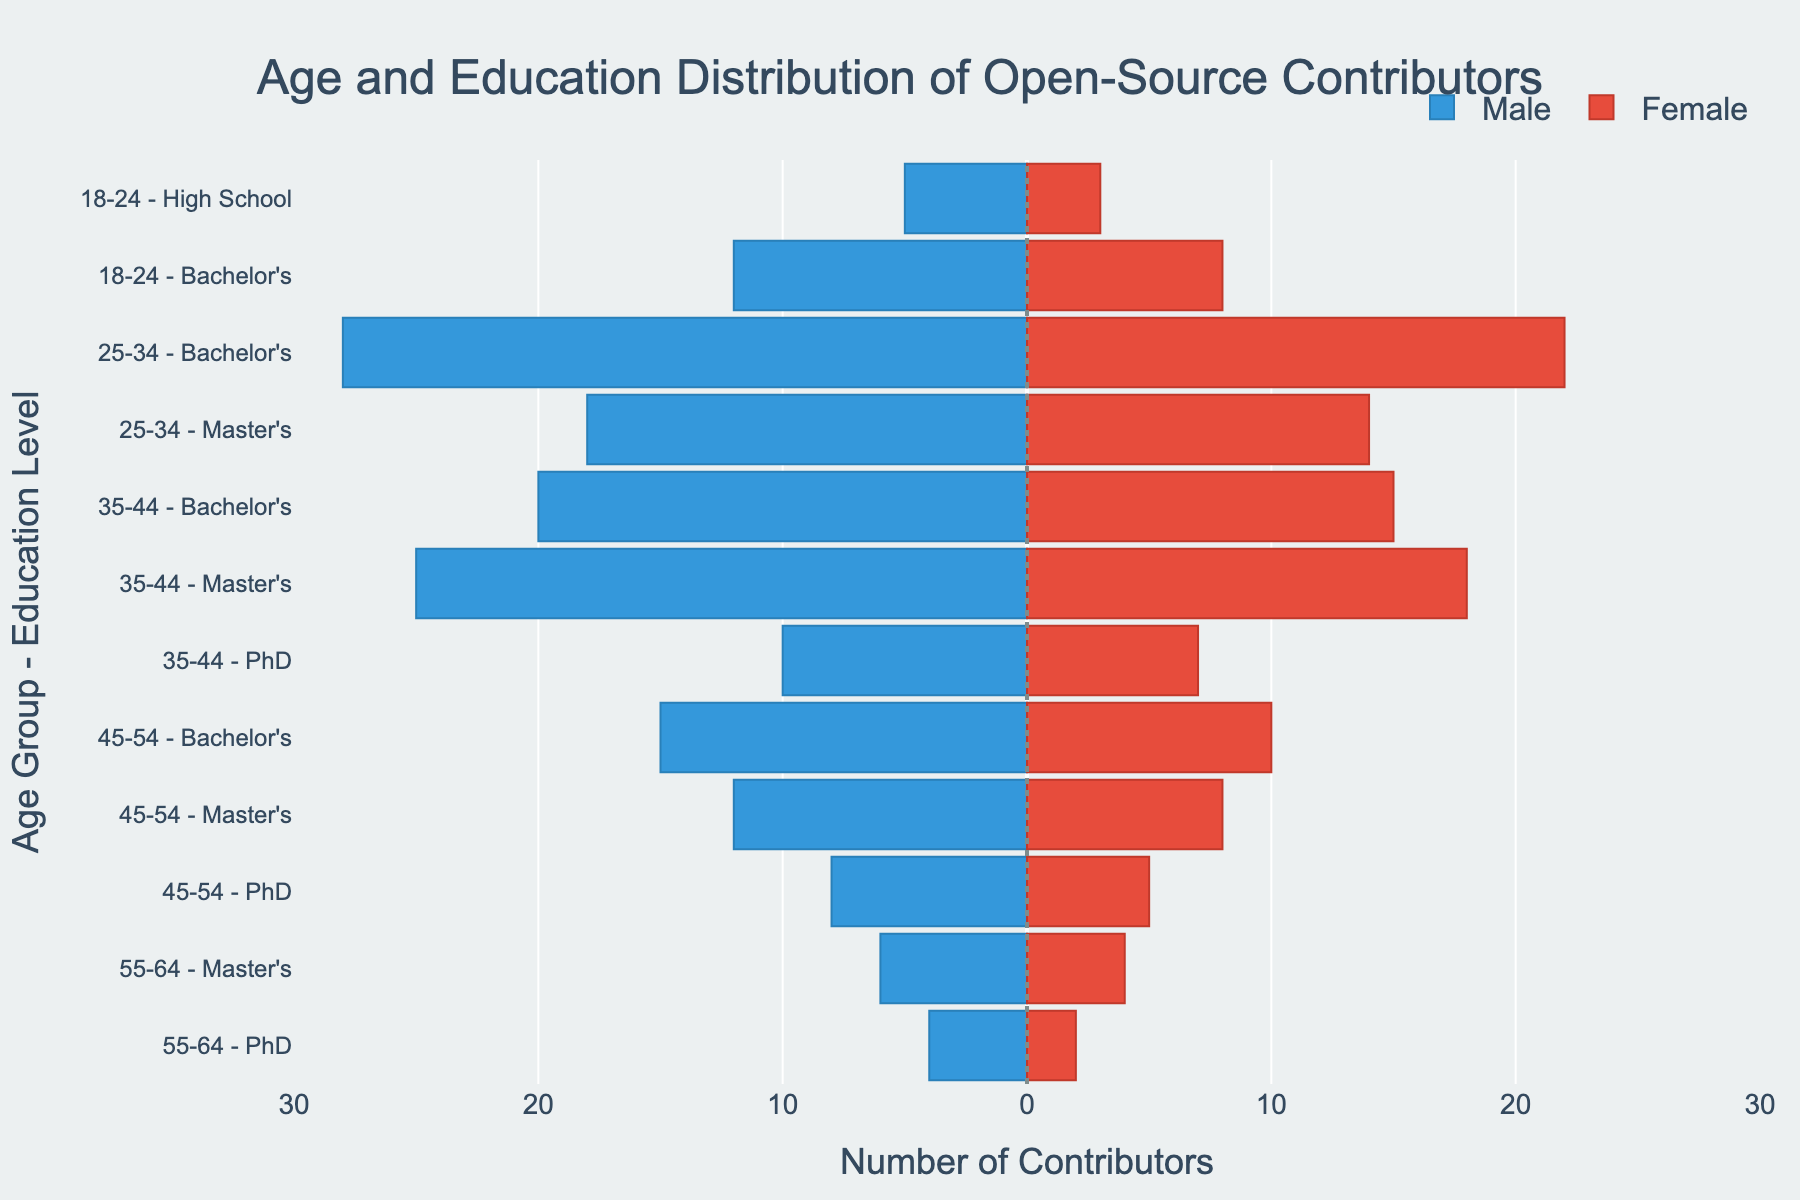Which age and education level combination has the most male contributors? The highest negative bar value represents the most male contributors. For age group 25-34 with a Bachelor's degree, the male contributor value is -28, the highest.
Answer: 25-34 Bachelor's Which age and education level combination has the most female contributors? The highest positive bar value represents the most female contributors. For age group 25-34 with a Bachelor's degree, the female contributor value is 22, the highest.
Answer: 25-34 Bachelor's How does the number of female contributors with a Master's degree in the 25-34 age group compare to male contributors in the same group? The number of female contributors is 14, and the number of male contributors is -18 (absolute value 18). Therefore, 14 < 18.
Answer: Fewer Which age group and education level have the fewest contributors in total? Sum the male and female values for each age and education level combination and compare. The combination 55-64 with a PhD has the smallest sum: 4 (male) + 2 (female) = 6
Answer: 55-64 PhD What is the combined number of contributors with a PhD degree across all age groups? Sum all the contributors with a PhD for males and females across all age groups: 10 (male) + 7 (female) + 8 (male) + 5 (female) + 4 (male) + 2 (female) = 36
Answer: 36 How many total contributors (both genders combined) are in the 18-24 age group? Sum the contributors for each gender in the 18-24 age group: 5 + 3 + 12 + 8 = 28
Answer: 28 Is there a gender disparity at the Master's level in the age group 25-34? If so, who contributes more? Compare the numbers directly: males are -18 and females are 14. There are more male contributors.
Answer: Yes, Males What age group has a more balanced gender distribution for PhD holders? Compare the gender counts of PhD holders across the groups: 
35-44 is 10 (male) and 7 (female) = difference of 3
45-54 is 8 (male) and 5 (female) = difference of 3
55-64 is 4 (male) and 2 (female) = difference of 2
The smallest difference is in the 55-64 group.
Answer: 55-64 